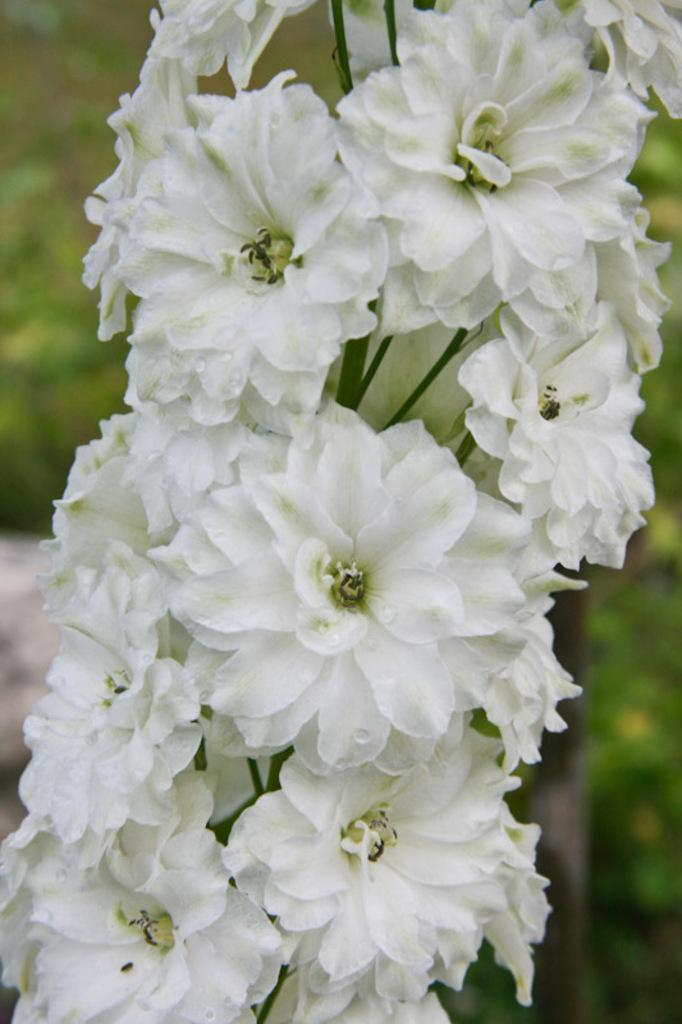What type of living organisms can be seen in the image? There are flowers in the image. What is the color of the flowers in the image? The flowers are white in color. What is the name of the daughter of the person who planted these flowers? There is no information about a person planting the flowers or having a daughter in the image, so this question cannot be answered definitively. 